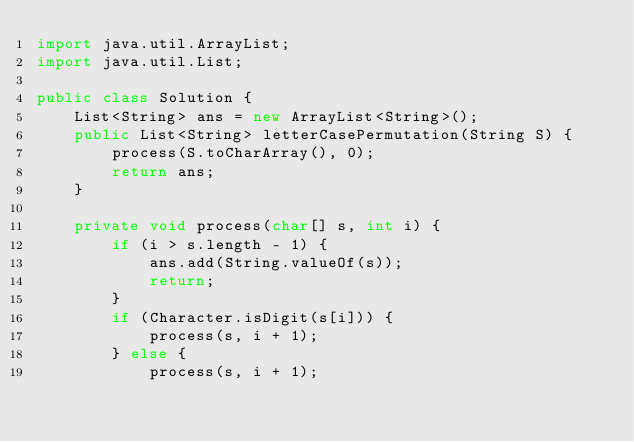Convert code to text. <code><loc_0><loc_0><loc_500><loc_500><_Java_>import java.util.ArrayList;
import java.util.List;

public class Solution {
    List<String> ans = new ArrayList<String>();
    public List<String> letterCasePermutation(String S) {
        process(S.toCharArray(), 0);
        return ans;
    }

    private void process(char[] s, int i) {
        if (i > s.length - 1) {
            ans.add(String.valueOf(s));
            return;
        }
        if (Character.isDigit(s[i])) {
            process(s, i + 1);
        } else {
            process(s, i + 1);</code> 